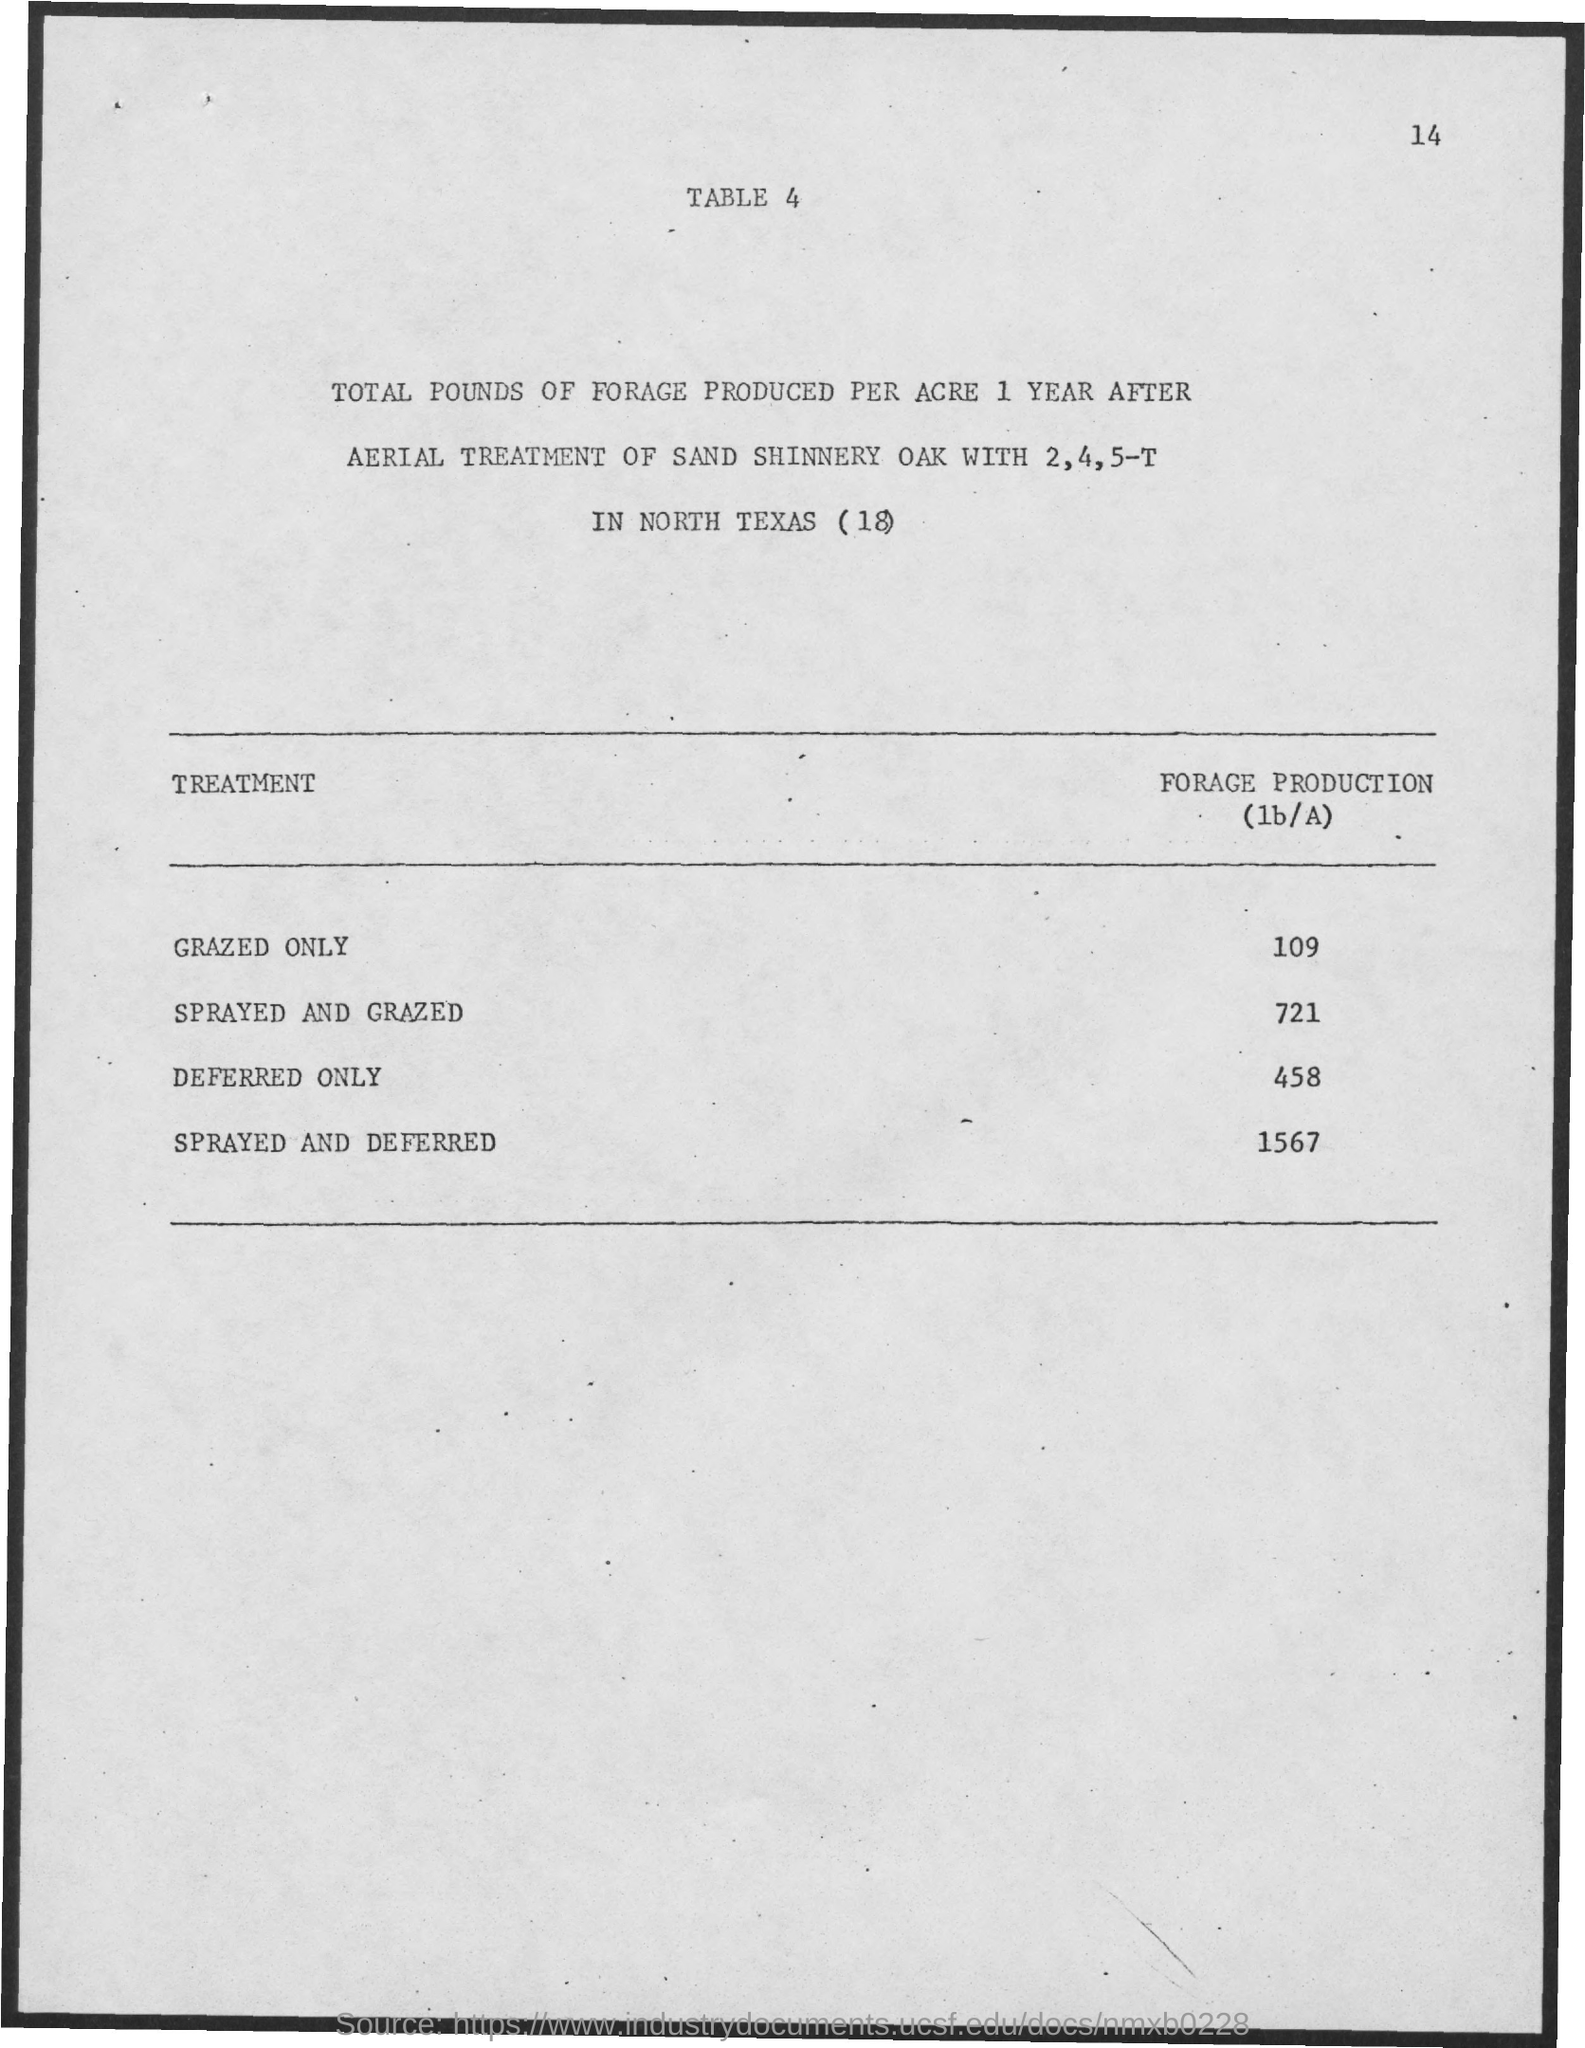What is the value of forage production for grazed only ?
Offer a very short reply. 109. What is the value of forage production for sprayed and grazed ?
Give a very brief answer. 721. What is the value of forage production for deferred only ?
Make the answer very short. 458. What is the value of forage production for sprayed and deferred ?
Your answer should be compact. 1567. 